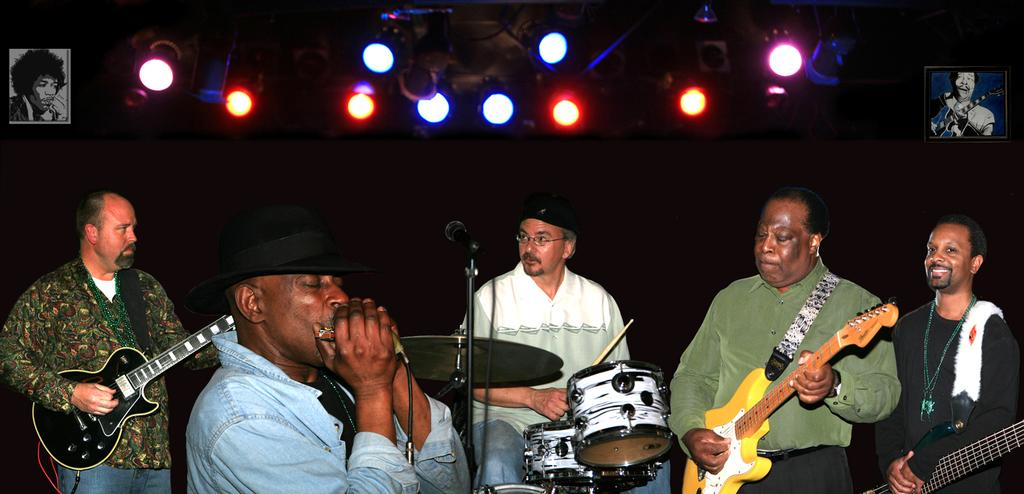What are the people in the image doing? The people in the image are standing and playing musical instruments. Can you describe the facial expression of one person in the image? One person on the right side is smiling. What can be seen in the background of the image? There are posters and lightnings visible in the background. What type of suit is the person on the left wearing in the image? There is no person wearing a suit in the image; they are all dressed casually while playing musical instruments. 